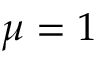<formula> <loc_0><loc_0><loc_500><loc_500>\mu = 1</formula> 